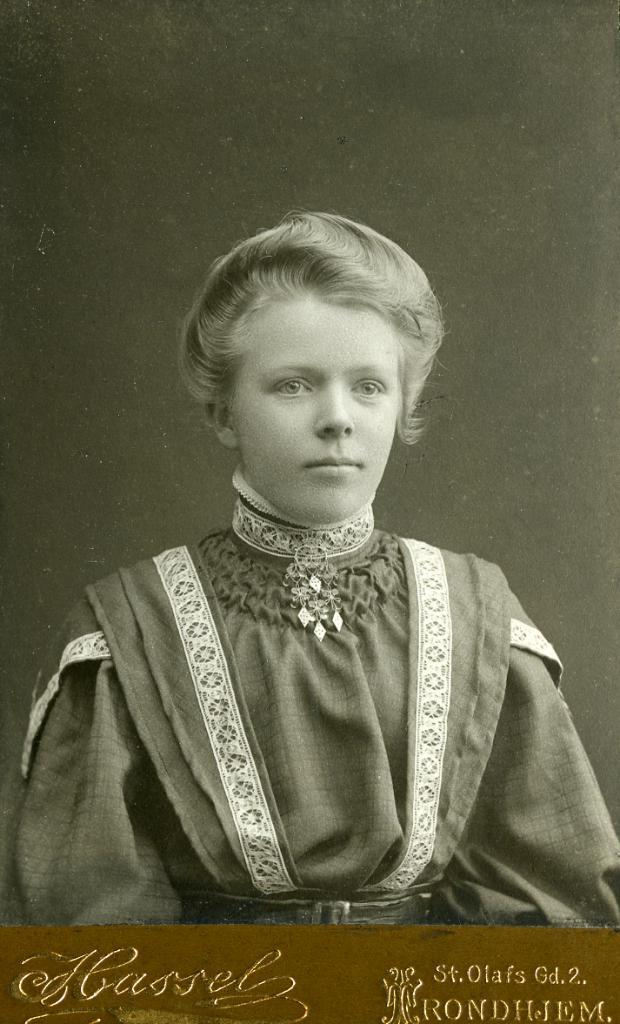Who or what is the main subject in the center of the image? There is a person in the center of the image. What information can be found at the bottom of the image? There is text written at the bottom of the image. What can be seen behind the person in the image? There is a wall in the background of the image. What type of stove is visible in the image? There is no stove present in the image. How many legs does the person in the image have? The person in the image has two legs, as is typical for humans. 